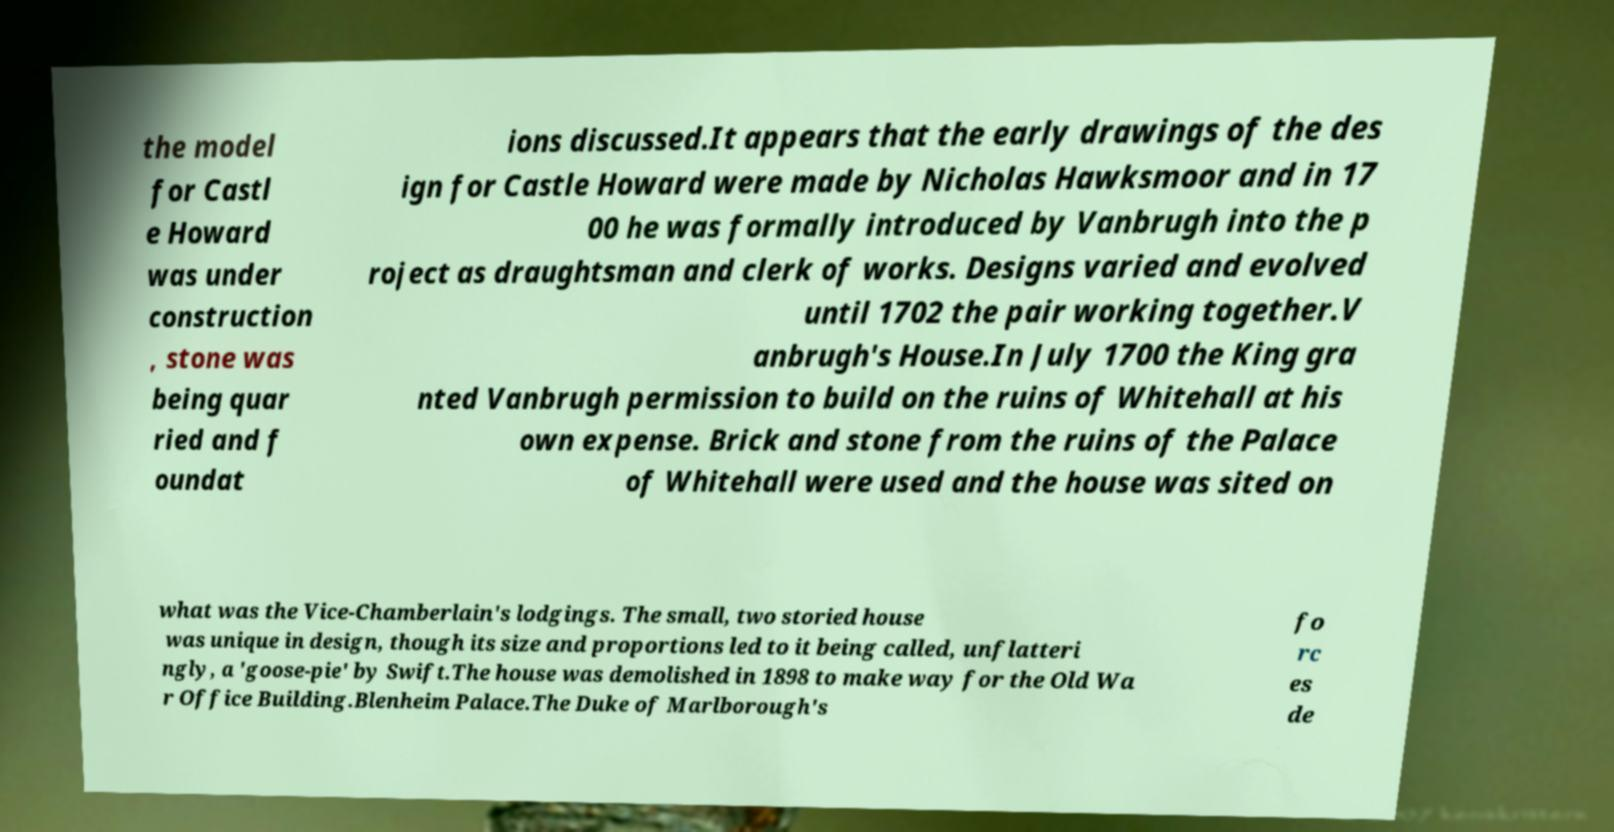There's text embedded in this image that I need extracted. Can you transcribe it verbatim? the model for Castl e Howard was under construction , stone was being quar ried and f oundat ions discussed.It appears that the early drawings of the des ign for Castle Howard were made by Nicholas Hawksmoor and in 17 00 he was formally introduced by Vanbrugh into the p roject as draughtsman and clerk of works. Designs varied and evolved until 1702 the pair working together.V anbrugh's House.In July 1700 the King gra nted Vanbrugh permission to build on the ruins of Whitehall at his own expense. Brick and stone from the ruins of the Palace of Whitehall were used and the house was sited on what was the Vice-Chamberlain's lodgings. The small, two storied house was unique in design, though its size and proportions led to it being called, unflatteri ngly, a 'goose-pie' by Swift.The house was demolished in 1898 to make way for the Old Wa r Office Building.Blenheim Palace.The Duke of Marlborough's fo rc es de 